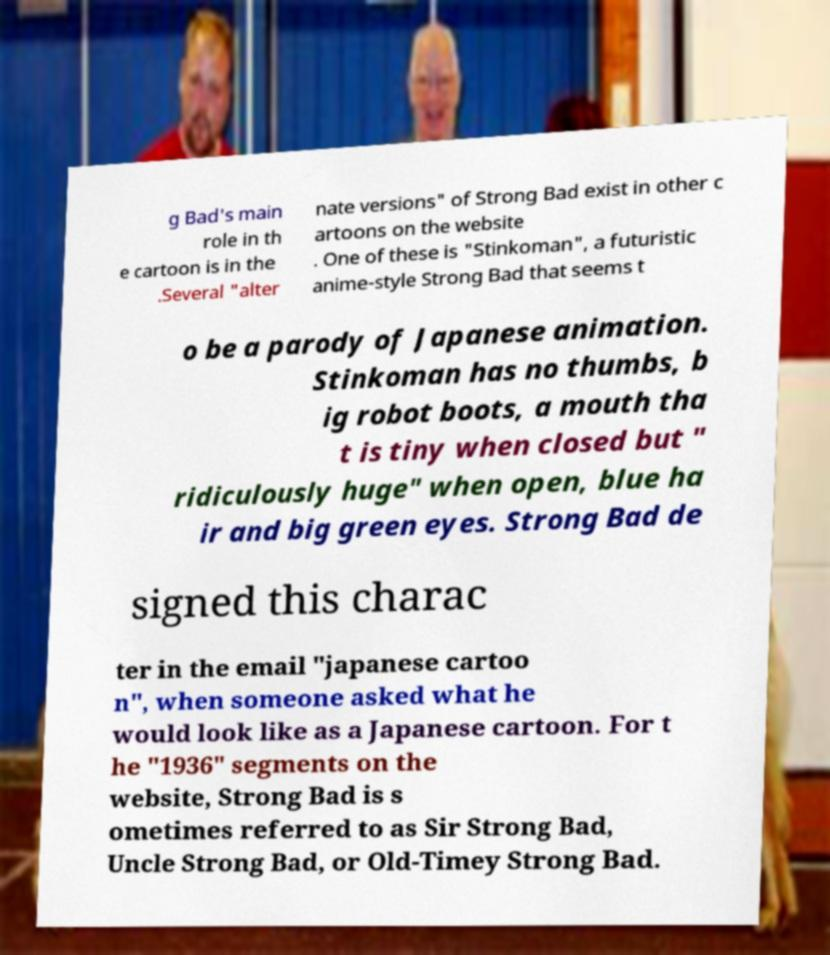Could you assist in decoding the text presented in this image and type it out clearly? g Bad's main role in th e cartoon is in the .Several "alter nate versions" of Strong Bad exist in other c artoons on the website . One of these is "Stinkoman", a futuristic anime-style Strong Bad that seems t o be a parody of Japanese animation. Stinkoman has no thumbs, b ig robot boots, a mouth tha t is tiny when closed but " ridiculously huge" when open, blue ha ir and big green eyes. Strong Bad de signed this charac ter in the email "japanese cartoo n", when someone asked what he would look like as a Japanese cartoon. For t he "1936" segments on the website, Strong Bad is s ometimes referred to as Sir Strong Bad, Uncle Strong Bad, or Old-Timey Strong Bad. 